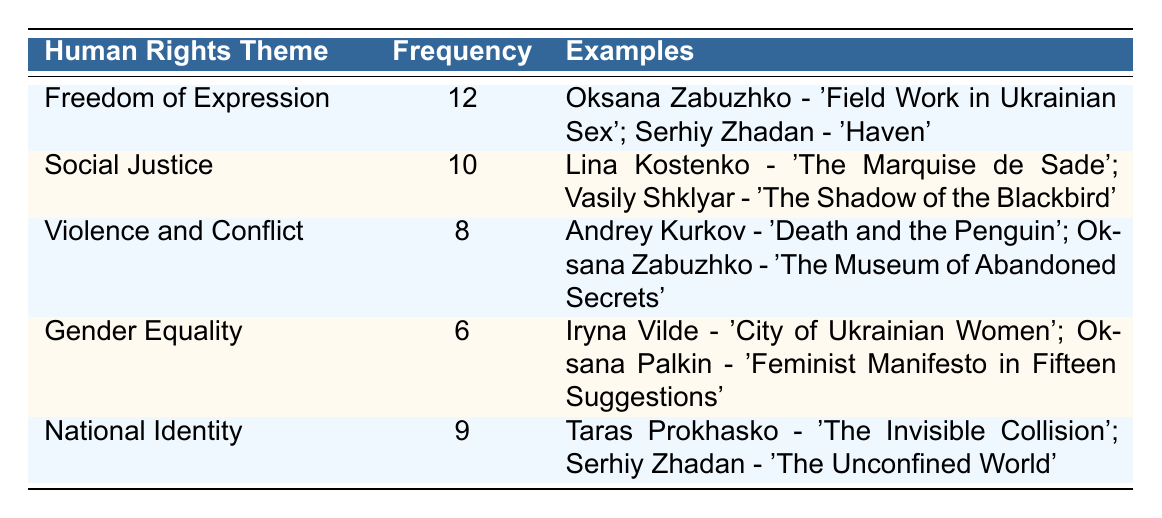What is the theme with the highest frequency? The table lists the frequencies of various human rights themes. By comparing the frequencies, we can see that "Freedom of Expression" has the highest frequency at 12.
Answer: Freedom of Expression How many themes are represented in this table? The table lists five different human rights themes under the "Human Rights Theme" column, indicating that there are five themes represented.
Answer: Five What examples are provided for the theme of National Identity? The table shows that "National Identity" has examples associated with it, specifically "Taras Prokhasko - 'The Invisible Collision'" and "Serhiy Zhadan - 'The Unconfined World'."
Answer: Taras Prokhasko - 'The Invisible Collision'; Serhiy Zhadan - 'The Unconfined World' Is there a theme with a frequency of 10? Looking through the frequency values, we see that "Social Justice" is counted with a frequency of 10, confirming that there is indeed a theme that matches this criterion.
Answer: Yes What is the total frequency of the themes related to Gender Equality and Violence and Conflict? By adding the frequencies of "Gender Equality" (6) and "Violence and Conflict" (8) together, we get a total of 14. Thus, the total frequency is 6 + 8 = 14.
Answer: 14 How many themes have a frequency greater than 8? Analyzing the frequency numbers, "Freedom of Expression" (12), "Social Justice" (10), and "Violence and Conflict" (8) have frequencies greater than 8, which makes it three themes in total.
Answer: Three Is "Violence and Conflict" the theme with the least frequency? Comparing the listed frequencies, "Gender Equality" has the least frequency at 6, which indicates that "Violence and Conflict" does not have the least frequency.
Answer: No What is the average frequency of all the themes listed in the table? To find the average, we sum all the frequencies: 12 + 10 + 8 + 6 + 9 = 55. Then, we divide by the number of themes (5). Thus, the average frequency is 55 / 5 = 11.
Answer: 11 Which theme is associated with the example "Feminist Manifesto in Fifteen Suggestions"? The example "Feminist Manifesto in Fifteen Suggestions" is found under the theme of "Gender Equality," showing its direct association.
Answer: Gender Equality 